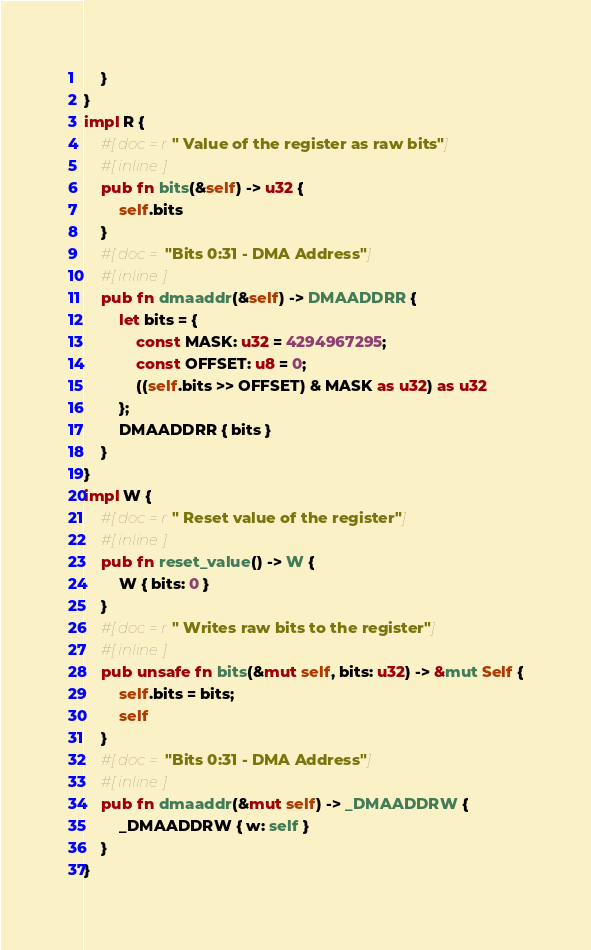Convert code to text. <code><loc_0><loc_0><loc_500><loc_500><_Rust_>    }
}
impl R {
    #[doc = r" Value of the register as raw bits"]
    #[inline]
    pub fn bits(&self) -> u32 {
        self.bits
    }
    #[doc = "Bits 0:31 - DMA Address"]
    #[inline]
    pub fn dmaaddr(&self) -> DMAADDRR {
        let bits = {
            const MASK: u32 = 4294967295;
            const OFFSET: u8 = 0;
            ((self.bits >> OFFSET) & MASK as u32) as u32
        };
        DMAADDRR { bits }
    }
}
impl W {
    #[doc = r" Reset value of the register"]
    #[inline]
    pub fn reset_value() -> W {
        W { bits: 0 }
    }
    #[doc = r" Writes raw bits to the register"]
    #[inline]
    pub unsafe fn bits(&mut self, bits: u32) -> &mut Self {
        self.bits = bits;
        self
    }
    #[doc = "Bits 0:31 - DMA Address"]
    #[inline]
    pub fn dmaaddr(&mut self) -> _DMAADDRW {
        _DMAADDRW { w: self }
    }
}
</code> 